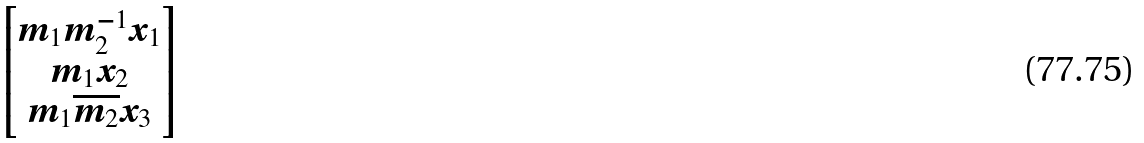<formula> <loc_0><loc_0><loc_500><loc_500>\begin{bmatrix} m _ { 1 } m _ { 2 } ^ { - 1 } x _ { 1 } \\ m _ { 1 } x _ { 2 } \\ m _ { 1 } \overline { m _ { 2 } } x _ { 3 } \end{bmatrix}</formula> 